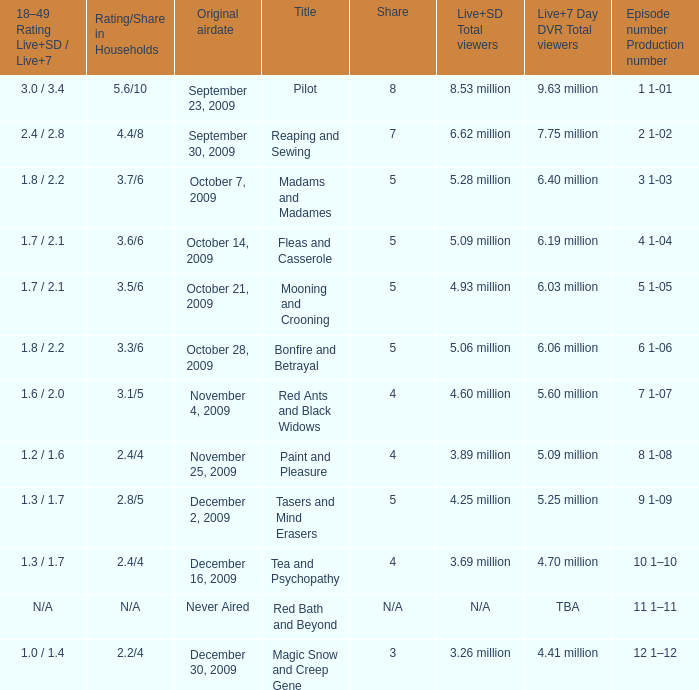Help me parse the entirety of this table. {'header': ['18–49 Rating Live+SD / Live+7', 'Rating/Share in Households', 'Original airdate', 'Title', 'Share', 'Live+SD Total viewers', 'Live+7 Day DVR Total viewers', 'Episode number Production number'], 'rows': [['3.0 / 3.4', '5.6/10', 'September 23, 2009', 'Pilot', '8', '8.53 million', '9.63 million', '1 1-01'], ['2.4 / 2.8', '4.4/8', 'September 30, 2009', 'Reaping and Sewing', '7', '6.62 million', '7.75 million', '2 1-02'], ['1.8 / 2.2', '3.7/6', 'October 7, 2009', 'Madams and Madames', '5', '5.28 million', '6.40 million', '3 1-03'], ['1.7 / 2.1', '3.6/6', 'October 14, 2009', 'Fleas and Casserole', '5', '5.09 million', '6.19 million', '4 1-04'], ['1.7 / 2.1', '3.5/6', 'October 21, 2009', 'Mooning and Crooning', '5', '4.93 million', '6.03 million', '5 1-05'], ['1.8 / 2.2', '3.3/6', 'October 28, 2009', 'Bonfire and Betrayal', '5', '5.06 million', '6.06 million', '6 1-06'], ['1.6 / 2.0', '3.1/5', 'November 4, 2009', 'Red Ants and Black Widows', '4', '4.60 million', '5.60 million', '7 1-07'], ['1.2 / 1.6', '2.4/4', 'November 25, 2009', 'Paint and Pleasure', '4', '3.89 million', '5.09 million', '8 1-08'], ['1.3 / 1.7', '2.8/5', 'December 2, 2009', 'Tasers and Mind Erasers', '5', '4.25 million', '5.25 million', '9 1-09'], ['1.3 / 1.7', '2.4/4', 'December 16, 2009', 'Tea and Psychopathy', '4', '3.69 million', '4.70 million', '10 1–10'], ['N/A', 'N/A', 'Never Aired', 'Red Bath and Beyond', 'N/A', 'N/A', 'TBA', '11 1–11'], ['1.0 / 1.4', '2.2/4', 'December 30, 2009', 'Magic Snow and Creep Gene', '3', '3.26 million', '4.41 million', '12 1–12']]} What are the "18–49 Rating Live+SD" ratings and "Live+7" ratings, respectively, for the episode that originally aired on October 14, 2009? 1.7 / 2.1. 